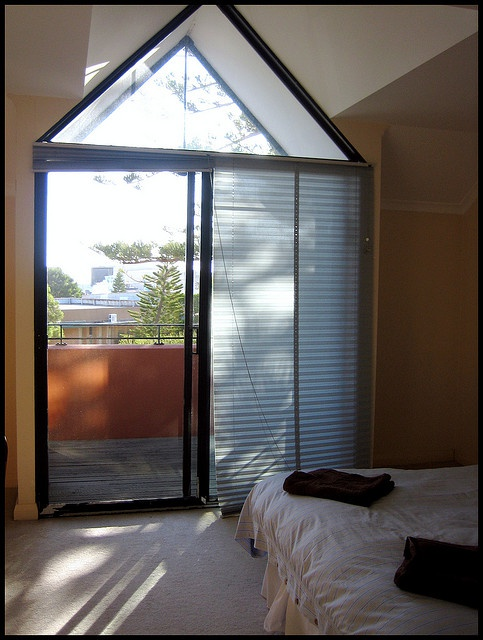Describe the objects in this image and their specific colors. I can see a bed in black and gray tones in this image. 